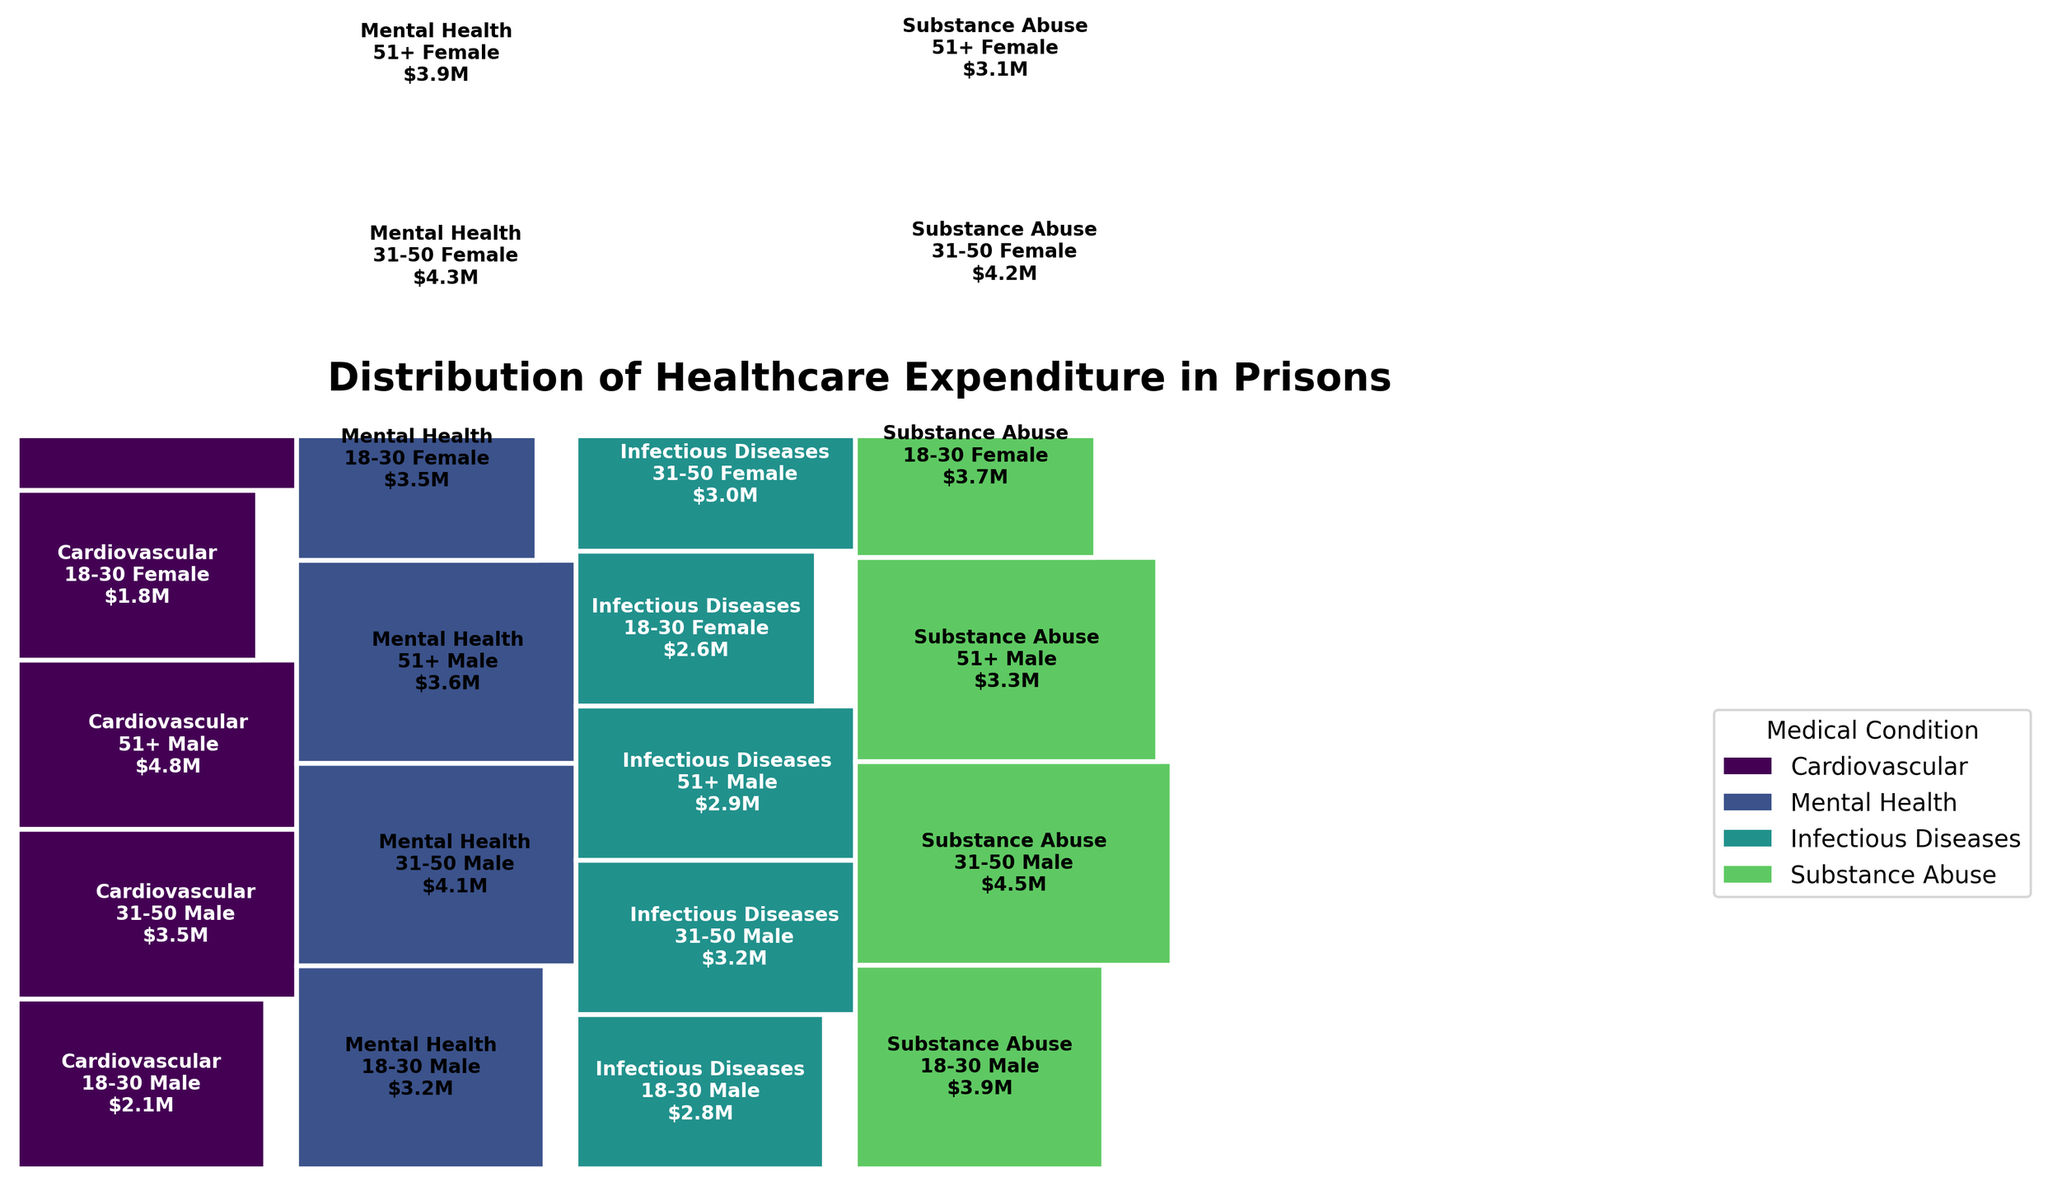What is the title of the figure? The title of the figure is usually prominently displayed at the top. By referencing it, one can directly read it to understand the main subject of the visualization.
Answer: Distribution of Healthcare Expenditure in Prisons Which medical condition has the highest expenditure for male inmates aged 51+? To find this, locate the ‘51+ Male’ demographic and visually compare the height of the rectangles under each medical condition for this demographic. The tallest one corresponds to the highest expenditure.
Answer: Cardiovascular How does the expenditure on substance abuse for female inmates aged 18-30 compare to that for male inmates aged 18-30? Identify the rectangles for 'Substance Abuse' under both '18-30 Male' and '18-30 Female' demographics. Compare their heights to determine which group has higher expenditure.
Answer: Female expenditure is lower What is the combined expenditure on cardiovascular conditions for all age groups of female inmates? Identify all rectangles under 'Cardiovascular' for all female demographics ('18-30', '31-50', '51+'). Sum up the expenditure values shown.
Answer: $8.5M Which demographic group has the smallest expenditure on infectious diseases? Locate the rectangles labeled 'Infectious Diseases' and visually compare them across all demographics to find the smallest one.
Answer: 51+ Female How does the total expenditure on mental health for all inmates compare to the total expenditure on cardiovascular conditions? Sum the expenditures for 'Mental Health' across all demographics and do the same for 'Cardiovascular'. Compare the two sums.
Answer: Mental health expenditure is slightly higher For the demographic '31-50 Female,' which medical condition has the lowest expenditure? Look at the ‘31-50 Female’ demographic and visually compare the height of rectangles for each medical condition to identify the smallest one.
Answer: Infectious Diseases If you were to rank the medical conditions by total expenditure across all demographics, what would be the order from highest to lowest? Sum the expenditures for each medical condition across all demographics and rank them from highest to lowest.
Answer: Substance Abuse, Cardiovascular, Mental Health, Infectious Diseases What is the total expenditure for male inmates aged 18-30 across all medical conditions? Sum the expenditures for all medical conditions under '18-30 Male.'
Answer: $12M Which gender generally has higher expenditures for cardiovascular conditions across all age groups? Compare the expenditures for 'Cardiovascular' across all age groups for both males and females. Sum these expenditures for each gender and compare.
Answer: Male 